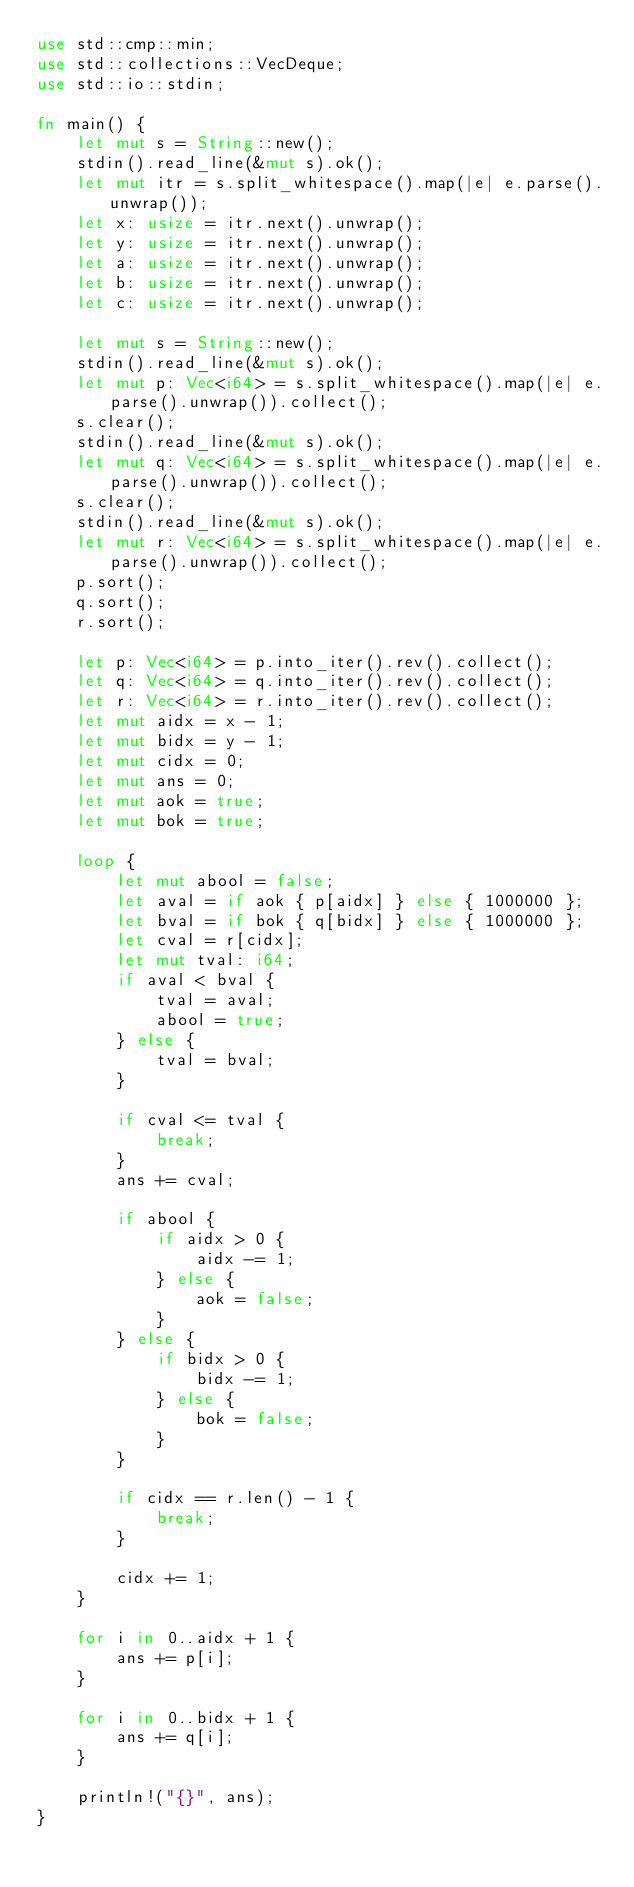Convert code to text. <code><loc_0><loc_0><loc_500><loc_500><_Rust_>use std::cmp::min;
use std::collections::VecDeque;
use std::io::stdin;

fn main() {
    let mut s = String::new();
    stdin().read_line(&mut s).ok();
    let mut itr = s.split_whitespace().map(|e| e.parse().unwrap());
    let x: usize = itr.next().unwrap();
    let y: usize = itr.next().unwrap();
    let a: usize = itr.next().unwrap();
    let b: usize = itr.next().unwrap();
    let c: usize = itr.next().unwrap();

    let mut s = String::new();
    stdin().read_line(&mut s).ok();
    let mut p: Vec<i64> = s.split_whitespace().map(|e| e.parse().unwrap()).collect();
    s.clear();
    stdin().read_line(&mut s).ok();
    let mut q: Vec<i64> = s.split_whitespace().map(|e| e.parse().unwrap()).collect();
    s.clear();
    stdin().read_line(&mut s).ok();
    let mut r: Vec<i64> = s.split_whitespace().map(|e| e.parse().unwrap()).collect();
    p.sort();
    q.sort();
    r.sort();

    let p: Vec<i64> = p.into_iter().rev().collect();
    let q: Vec<i64> = q.into_iter().rev().collect();
    let r: Vec<i64> = r.into_iter().rev().collect();
    let mut aidx = x - 1;
    let mut bidx = y - 1;
    let mut cidx = 0;
    let mut ans = 0;
    let mut aok = true;
    let mut bok = true;

    loop {
        let mut abool = false;
        let aval = if aok { p[aidx] } else { 1000000 };
        let bval = if bok { q[bidx] } else { 1000000 };
        let cval = r[cidx];
        let mut tval: i64;
        if aval < bval {
            tval = aval;
            abool = true;
        } else {
            tval = bval;
        }

        if cval <= tval {
            break;
        }
        ans += cval;

        if abool {
            if aidx > 0 {
                aidx -= 1;
            } else {
                aok = false;
            }
        } else {
            if bidx > 0 {
                bidx -= 1;
            } else {
                bok = false;
            }
        }

        if cidx == r.len() - 1 {
            break;
        }

        cidx += 1;
    }

    for i in 0..aidx + 1 {
        ans += p[i];
    }

    for i in 0..bidx + 1 {
        ans += q[i];
    }

    println!("{}", ans);
}
</code> 